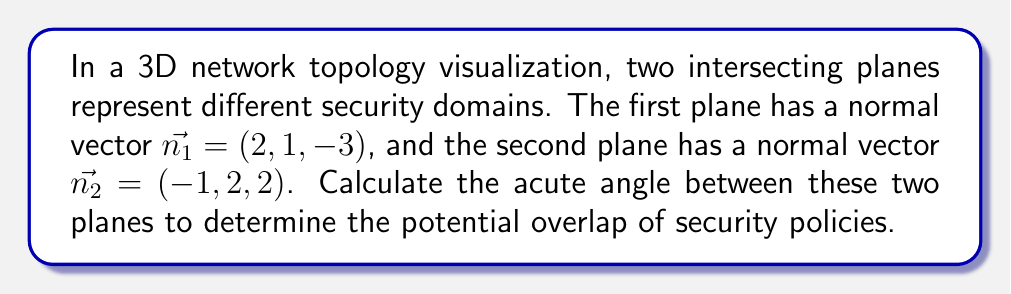Solve this math problem. To find the angle between two intersecting planes, we can use the angle between their normal vectors. The process is as follows:

1. We have the normal vectors:
   $\vec{n_1} = (2, 1, -3)$ and $\vec{n_2} = (-1, 2, 2)$

2. The angle $\theta$ between two vectors $\vec{a}$ and $\vec{b}$ is given by the formula:
   $$\cos \theta = \frac{\vec{a} \cdot \vec{b}}{|\vec{a}||\vec{b}|}$$

3. Calculate the dot product $\vec{n_1} \cdot \vec{n_2}$:
   $$(2)(-1) + (1)(2) + (-3)(2) = -2 + 2 - 6 = -6$$

4. Calculate the magnitudes of the vectors:
   $$|\vec{n_1}| = \sqrt{2^2 + 1^2 + (-3)^2} = \sqrt{4 + 1 + 9} = \sqrt{14}$$
   $$|\vec{n_2}| = \sqrt{(-1)^2 + 2^2 + 2^2} = \sqrt{1 + 4 + 4} = 3$$

5. Substitute into the formula:
   $$\cos \theta = \frac{-6}{\sqrt{14} \cdot 3} = \frac{-6}{3\sqrt{14}}$$

6. Take the inverse cosine (arccos) of both sides:
   $$\theta = \arccos\left(\frac{-6}{3\sqrt{14}}\right)$$

7. Calculate the result (in radians) and convert to degrees:
   $$\theta \approx 2.0344 \text{ radians} \approx 116.57°$$

8. Since we want the acute angle, we subtract this from 180°:
   $$180° - 116.57° = 63.43°$$
Answer: $63.43°$ 